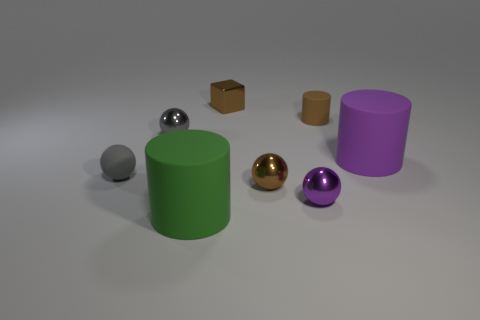Subtract all blue balls. Subtract all brown cylinders. How many balls are left? 4 Add 1 small blue rubber cubes. How many objects exist? 9 Subtract all blocks. How many objects are left? 7 Subtract all purple metallic spheres. Subtract all small gray metallic things. How many objects are left? 6 Add 6 small rubber cylinders. How many small rubber cylinders are left? 7 Add 5 tiny brown objects. How many tiny brown objects exist? 8 Subtract 0 cyan cubes. How many objects are left? 8 